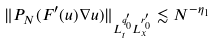<formula> <loc_0><loc_0><loc_500><loc_500>\| P _ { N } ( F ^ { \prime } ( u ) \nabla u ) \| _ { L ^ { q ^ { \prime } _ { 0 } } _ { t } L ^ { r ^ { \prime } _ { 0 } } _ { x } } \lesssim N ^ { - \eta _ { 1 } }</formula> 